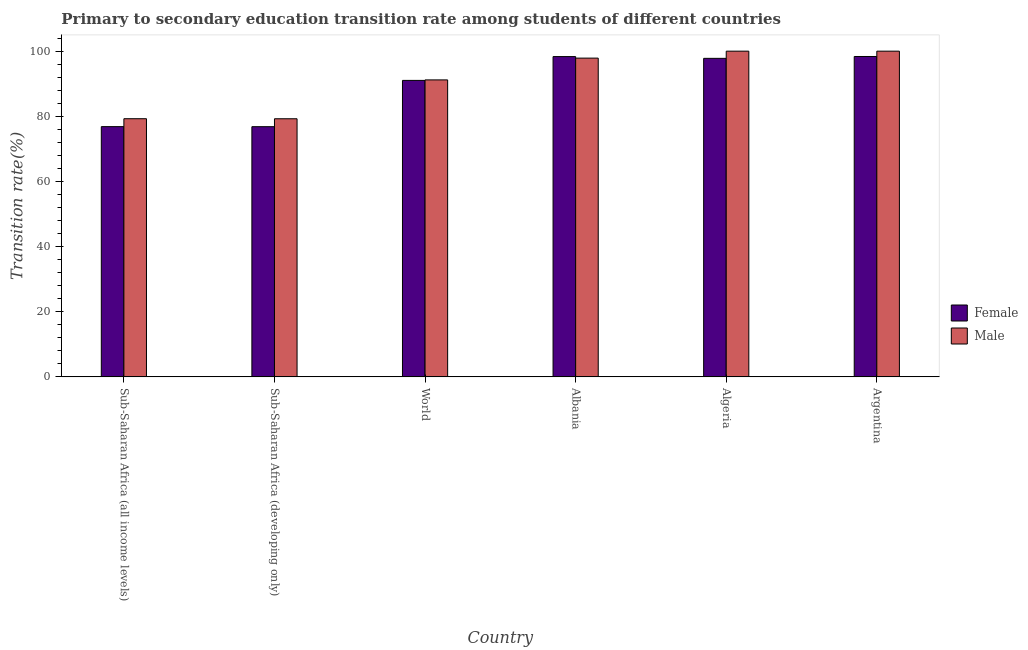Are the number of bars per tick equal to the number of legend labels?
Your response must be concise. Yes. How many bars are there on the 2nd tick from the left?
Ensure brevity in your answer.  2. How many bars are there on the 4th tick from the right?
Offer a terse response. 2. What is the label of the 5th group of bars from the left?
Make the answer very short. Algeria. What is the transition rate among female students in Algeria?
Provide a short and direct response. 97.79. Across all countries, what is the maximum transition rate among female students?
Offer a very short reply. 98.36. Across all countries, what is the minimum transition rate among male students?
Your response must be concise. 79.25. In which country was the transition rate among male students maximum?
Offer a terse response. Algeria. In which country was the transition rate among male students minimum?
Provide a succinct answer. Sub-Saharan Africa (developing only). What is the total transition rate among male students in the graph?
Your answer should be compact. 547.55. What is the difference between the transition rate among male students in Albania and that in Sub-Saharan Africa (developing only)?
Provide a succinct answer. 18.62. What is the difference between the transition rate among male students in Sub-Saharan Africa (all income levels) and the transition rate among female students in Argentina?
Offer a terse response. -19.1. What is the average transition rate among female students per country?
Keep it short and to the point. 89.86. What is the difference between the transition rate among female students and transition rate among male students in Albania?
Your response must be concise. 0.47. What is the ratio of the transition rate among male students in Albania to that in World?
Your response must be concise. 1.07. Is the transition rate among male students in Albania less than that in World?
Provide a succinct answer. No. What is the difference between the highest and the second highest transition rate among female students?
Make the answer very short. 0.03. What is the difference between the highest and the lowest transition rate among male students?
Keep it short and to the point. 20.75. Is the sum of the transition rate among male students in Albania and Argentina greater than the maximum transition rate among female students across all countries?
Your response must be concise. Yes. What does the 2nd bar from the right in Argentina represents?
Ensure brevity in your answer.  Female. How many bars are there?
Give a very brief answer. 12. What is the difference between two consecutive major ticks on the Y-axis?
Your answer should be compact. 20. Are the values on the major ticks of Y-axis written in scientific E-notation?
Provide a short and direct response. No. Does the graph contain grids?
Provide a short and direct response. No. Where does the legend appear in the graph?
Your response must be concise. Center right. How many legend labels are there?
Provide a succinct answer. 2. How are the legend labels stacked?
Give a very brief answer. Vertical. What is the title of the graph?
Offer a very short reply. Primary to secondary education transition rate among students of different countries. What is the label or title of the Y-axis?
Give a very brief answer. Transition rate(%). What is the Transition rate(%) in Female in Sub-Saharan Africa (all income levels)?
Offer a terse response. 76.83. What is the Transition rate(%) in Male in Sub-Saharan Africa (all income levels)?
Keep it short and to the point. 79.26. What is the Transition rate(%) in Female in Sub-Saharan Africa (developing only)?
Provide a short and direct response. 76.81. What is the Transition rate(%) in Male in Sub-Saharan Africa (developing only)?
Make the answer very short. 79.25. What is the Transition rate(%) in Female in World?
Your answer should be compact. 91.02. What is the Transition rate(%) of Male in World?
Your answer should be compact. 91.18. What is the Transition rate(%) of Female in Albania?
Your answer should be compact. 98.33. What is the Transition rate(%) of Male in Albania?
Provide a succinct answer. 97.86. What is the Transition rate(%) of Female in Algeria?
Provide a succinct answer. 97.79. What is the Transition rate(%) in Male in Algeria?
Your answer should be very brief. 100. What is the Transition rate(%) of Female in Argentina?
Your answer should be very brief. 98.36. Across all countries, what is the maximum Transition rate(%) of Female?
Provide a succinct answer. 98.36. Across all countries, what is the minimum Transition rate(%) of Female?
Make the answer very short. 76.81. Across all countries, what is the minimum Transition rate(%) in Male?
Your answer should be very brief. 79.25. What is the total Transition rate(%) of Female in the graph?
Your answer should be very brief. 539.15. What is the total Transition rate(%) of Male in the graph?
Provide a short and direct response. 547.55. What is the difference between the Transition rate(%) of Female in Sub-Saharan Africa (all income levels) and that in Sub-Saharan Africa (developing only)?
Give a very brief answer. 0.01. What is the difference between the Transition rate(%) of Male in Sub-Saharan Africa (all income levels) and that in Sub-Saharan Africa (developing only)?
Your response must be concise. 0.01. What is the difference between the Transition rate(%) of Female in Sub-Saharan Africa (all income levels) and that in World?
Your answer should be compact. -14.2. What is the difference between the Transition rate(%) in Male in Sub-Saharan Africa (all income levels) and that in World?
Your answer should be very brief. -11.92. What is the difference between the Transition rate(%) of Female in Sub-Saharan Africa (all income levels) and that in Albania?
Give a very brief answer. -21.51. What is the difference between the Transition rate(%) in Male in Sub-Saharan Africa (all income levels) and that in Albania?
Provide a short and direct response. -18.6. What is the difference between the Transition rate(%) of Female in Sub-Saharan Africa (all income levels) and that in Algeria?
Make the answer very short. -20.96. What is the difference between the Transition rate(%) in Male in Sub-Saharan Africa (all income levels) and that in Algeria?
Your response must be concise. -20.74. What is the difference between the Transition rate(%) of Female in Sub-Saharan Africa (all income levels) and that in Argentina?
Your answer should be compact. -21.54. What is the difference between the Transition rate(%) in Male in Sub-Saharan Africa (all income levels) and that in Argentina?
Keep it short and to the point. -20.74. What is the difference between the Transition rate(%) in Female in Sub-Saharan Africa (developing only) and that in World?
Make the answer very short. -14.21. What is the difference between the Transition rate(%) in Male in Sub-Saharan Africa (developing only) and that in World?
Make the answer very short. -11.93. What is the difference between the Transition rate(%) of Female in Sub-Saharan Africa (developing only) and that in Albania?
Give a very brief answer. -21.52. What is the difference between the Transition rate(%) in Male in Sub-Saharan Africa (developing only) and that in Albania?
Offer a terse response. -18.62. What is the difference between the Transition rate(%) of Female in Sub-Saharan Africa (developing only) and that in Algeria?
Provide a succinct answer. -20.98. What is the difference between the Transition rate(%) of Male in Sub-Saharan Africa (developing only) and that in Algeria?
Ensure brevity in your answer.  -20.75. What is the difference between the Transition rate(%) of Female in Sub-Saharan Africa (developing only) and that in Argentina?
Your response must be concise. -21.55. What is the difference between the Transition rate(%) in Male in Sub-Saharan Africa (developing only) and that in Argentina?
Your response must be concise. -20.75. What is the difference between the Transition rate(%) of Female in World and that in Albania?
Offer a terse response. -7.31. What is the difference between the Transition rate(%) in Male in World and that in Albania?
Your answer should be compact. -6.69. What is the difference between the Transition rate(%) in Female in World and that in Algeria?
Keep it short and to the point. -6.77. What is the difference between the Transition rate(%) of Male in World and that in Algeria?
Keep it short and to the point. -8.82. What is the difference between the Transition rate(%) of Female in World and that in Argentina?
Make the answer very short. -7.34. What is the difference between the Transition rate(%) in Male in World and that in Argentina?
Offer a very short reply. -8.82. What is the difference between the Transition rate(%) of Female in Albania and that in Algeria?
Your answer should be very brief. 0.54. What is the difference between the Transition rate(%) in Male in Albania and that in Algeria?
Give a very brief answer. -2.14. What is the difference between the Transition rate(%) in Female in Albania and that in Argentina?
Keep it short and to the point. -0.03. What is the difference between the Transition rate(%) of Male in Albania and that in Argentina?
Your answer should be compact. -2.14. What is the difference between the Transition rate(%) in Female in Algeria and that in Argentina?
Your response must be concise. -0.57. What is the difference between the Transition rate(%) in Male in Algeria and that in Argentina?
Provide a short and direct response. 0. What is the difference between the Transition rate(%) in Female in Sub-Saharan Africa (all income levels) and the Transition rate(%) in Male in Sub-Saharan Africa (developing only)?
Your response must be concise. -2.42. What is the difference between the Transition rate(%) in Female in Sub-Saharan Africa (all income levels) and the Transition rate(%) in Male in World?
Provide a short and direct response. -14.35. What is the difference between the Transition rate(%) in Female in Sub-Saharan Africa (all income levels) and the Transition rate(%) in Male in Albania?
Give a very brief answer. -21.04. What is the difference between the Transition rate(%) of Female in Sub-Saharan Africa (all income levels) and the Transition rate(%) of Male in Algeria?
Offer a very short reply. -23.17. What is the difference between the Transition rate(%) in Female in Sub-Saharan Africa (all income levels) and the Transition rate(%) in Male in Argentina?
Your response must be concise. -23.17. What is the difference between the Transition rate(%) in Female in Sub-Saharan Africa (developing only) and the Transition rate(%) in Male in World?
Your answer should be compact. -14.36. What is the difference between the Transition rate(%) of Female in Sub-Saharan Africa (developing only) and the Transition rate(%) of Male in Albania?
Make the answer very short. -21.05. What is the difference between the Transition rate(%) of Female in Sub-Saharan Africa (developing only) and the Transition rate(%) of Male in Algeria?
Your answer should be compact. -23.19. What is the difference between the Transition rate(%) of Female in Sub-Saharan Africa (developing only) and the Transition rate(%) of Male in Argentina?
Offer a terse response. -23.19. What is the difference between the Transition rate(%) of Female in World and the Transition rate(%) of Male in Albania?
Provide a short and direct response. -6.84. What is the difference between the Transition rate(%) of Female in World and the Transition rate(%) of Male in Algeria?
Offer a terse response. -8.98. What is the difference between the Transition rate(%) in Female in World and the Transition rate(%) in Male in Argentina?
Your response must be concise. -8.98. What is the difference between the Transition rate(%) in Female in Albania and the Transition rate(%) in Male in Algeria?
Your answer should be compact. -1.67. What is the difference between the Transition rate(%) of Female in Albania and the Transition rate(%) of Male in Argentina?
Provide a succinct answer. -1.67. What is the difference between the Transition rate(%) of Female in Algeria and the Transition rate(%) of Male in Argentina?
Give a very brief answer. -2.21. What is the average Transition rate(%) of Female per country?
Offer a terse response. 89.86. What is the average Transition rate(%) in Male per country?
Keep it short and to the point. 91.26. What is the difference between the Transition rate(%) of Female and Transition rate(%) of Male in Sub-Saharan Africa (all income levels)?
Your answer should be very brief. -2.43. What is the difference between the Transition rate(%) of Female and Transition rate(%) of Male in Sub-Saharan Africa (developing only)?
Provide a succinct answer. -2.43. What is the difference between the Transition rate(%) of Female and Transition rate(%) of Male in World?
Keep it short and to the point. -0.15. What is the difference between the Transition rate(%) in Female and Transition rate(%) in Male in Albania?
Ensure brevity in your answer.  0.47. What is the difference between the Transition rate(%) in Female and Transition rate(%) in Male in Algeria?
Give a very brief answer. -2.21. What is the difference between the Transition rate(%) in Female and Transition rate(%) in Male in Argentina?
Your response must be concise. -1.64. What is the ratio of the Transition rate(%) in Female in Sub-Saharan Africa (all income levels) to that in Sub-Saharan Africa (developing only)?
Your answer should be very brief. 1. What is the ratio of the Transition rate(%) in Male in Sub-Saharan Africa (all income levels) to that in Sub-Saharan Africa (developing only)?
Keep it short and to the point. 1. What is the ratio of the Transition rate(%) of Female in Sub-Saharan Africa (all income levels) to that in World?
Make the answer very short. 0.84. What is the ratio of the Transition rate(%) in Male in Sub-Saharan Africa (all income levels) to that in World?
Keep it short and to the point. 0.87. What is the ratio of the Transition rate(%) in Female in Sub-Saharan Africa (all income levels) to that in Albania?
Keep it short and to the point. 0.78. What is the ratio of the Transition rate(%) in Male in Sub-Saharan Africa (all income levels) to that in Albania?
Your answer should be very brief. 0.81. What is the ratio of the Transition rate(%) of Female in Sub-Saharan Africa (all income levels) to that in Algeria?
Your answer should be very brief. 0.79. What is the ratio of the Transition rate(%) in Male in Sub-Saharan Africa (all income levels) to that in Algeria?
Your answer should be compact. 0.79. What is the ratio of the Transition rate(%) in Female in Sub-Saharan Africa (all income levels) to that in Argentina?
Provide a short and direct response. 0.78. What is the ratio of the Transition rate(%) of Male in Sub-Saharan Africa (all income levels) to that in Argentina?
Your answer should be compact. 0.79. What is the ratio of the Transition rate(%) in Female in Sub-Saharan Africa (developing only) to that in World?
Keep it short and to the point. 0.84. What is the ratio of the Transition rate(%) in Male in Sub-Saharan Africa (developing only) to that in World?
Offer a terse response. 0.87. What is the ratio of the Transition rate(%) in Female in Sub-Saharan Africa (developing only) to that in Albania?
Your response must be concise. 0.78. What is the ratio of the Transition rate(%) of Male in Sub-Saharan Africa (developing only) to that in Albania?
Give a very brief answer. 0.81. What is the ratio of the Transition rate(%) of Female in Sub-Saharan Africa (developing only) to that in Algeria?
Provide a succinct answer. 0.79. What is the ratio of the Transition rate(%) of Male in Sub-Saharan Africa (developing only) to that in Algeria?
Provide a succinct answer. 0.79. What is the ratio of the Transition rate(%) of Female in Sub-Saharan Africa (developing only) to that in Argentina?
Offer a terse response. 0.78. What is the ratio of the Transition rate(%) of Male in Sub-Saharan Africa (developing only) to that in Argentina?
Your response must be concise. 0.79. What is the ratio of the Transition rate(%) of Female in World to that in Albania?
Make the answer very short. 0.93. What is the ratio of the Transition rate(%) in Male in World to that in Albania?
Provide a short and direct response. 0.93. What is the ratio of the Transition rate(%) in Female in World to that in Algeria?
Your response must be concise. 0.93. What is the ratio of the Transition rate(%) in Male in World to that in Algeria?
Keep it short and to the point. 0.91. What is the ratio of the Transition rate(%) in Female in World to that in Argentina?
Offer a terse response. 0.93. What is the ratio of the Transition rate(%) in Male in World to that in Argentina?
Ensure brevity in your answer.  0.91. What is the ratio of the Transition rate(%) of Female in Albania to that in Algeria?
Your answer should be compact. 1.01. What is the ratio of the Transition rate(%) of Male in Albania to that in Algeria?
Your response must be concise. 0.98. What is the ratio of the Transition rate(%) in Female in Albania to that in Argentina?
Give a very brief answer. 1. What is the ratio of the Transition rate(%) in Male in Albania to that in Argentina?
Offer a terse response. 0.98. What is the ratio of the Transition rate(%) in Female in Algeria to that in Argentina?
Give a very brief answer. 0.99. What is the difference between the highest and the second highest Transition rate(%) in Female?
Offer a very short reply. 0.03. What is the difference between the highest and the lowest Transition rate(%) in Female?
Provide a succinct answer. 21.55. What is the difference between the highest and the lowest Transition rate(%) of Male?
Offer a terse response. 20.75. 